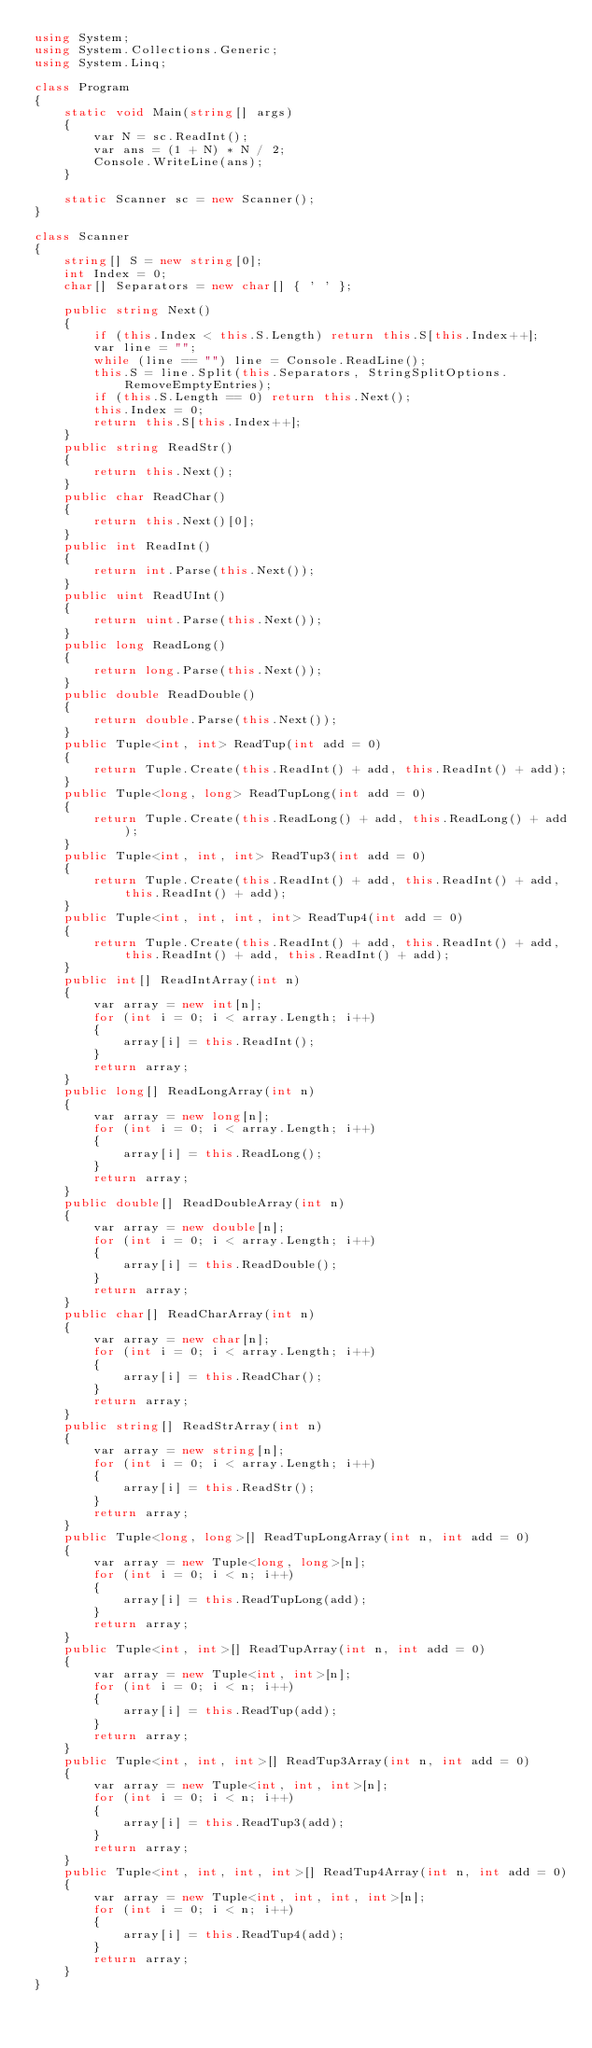Convert code to text. <code><loc_0><loc_0><loc_500><loc_500><_C#_>using System;
using System.Collections.Generic;
using System.Linq;

class Program
{
    static void Main(string[] args)
    {
        var N = sc.ReadInt();
        var ans = (1 + N) * N / 2;
        Console.WriteLine(ans);
    }

    static Scanner sc = new Scanner();
}

class Scanner
{
    string[] S = new string[0];
    int Index = 0;
    char[] Separators = new char[] { ' ' };

    public string Next()
    {
        if (this.Index < this.S.Length) return this.S[this.Index++];
        var line = "";
        while (line == "") line = Console.ReadLine();
        this.S = line.Split(this.Separators, StringSplitOptions.RemoveEmptyEntries);
        if (this.S.Length == 0) return this.Next();
        this.Index = 0;
        return this.S[this.Index++];
    }
    public string ReadStr()
    {
        return this.Next();
    }
    public char ReadChar()
    {
        return this.Next()[0];
    }
    public int ReadInt()
    {
        return int.Parse(this.Next());
    }
    public uint ReadUInt()
    {
        return uint.Parse(this.Next());
    }
    public long ReadLong()
    {
        return long.Parse(this.Next());
    }
    public double ReadDouble()
    {
        return double.Parse(this.Next());
    }
    public Tuple<int, int> ReadTup(int add = 0)
    {
        return Tuple.Create(this.ReadInt() + add, this.ReadInt() + add);
    }
    public Tuple<long, long> ReadTupLong(int add = 0)
    {
        return Tuple.Create(this.ReadLong() + add, this.ReadLong() + add);
    }
    public Tuple<int, int, int> ReadTup3(int add = 0)
    {
        return Tuple.Create(this.ReadInt() + add, this.ReadInt() + add, this.ReadInt() + add);
    }
    public Tuple<int, int, int, int> ReadTup4(int add = 0)
    {
        return Tuple.Create(this.ReadInt() + add, this.ReadInt() + add, this.ReadInt() + add, this.ReadInt() + add);
    }
    public int[] ReadIntArray(int n)
    {
        var array = new int[n];
        for (int i = 0; i < array.Length; i++)
        {
            array[i] = this.ReadInt();
        }
        return array;
    }
    public long[] ReadLongArray(int n)
    {
        var array = new long[n];
        for (int i = 0; i < array.Length; i++)
        {
            array[i] = this.ReadLong();
        }
        return array;
    }
    public double[] ReadDoubleArray(int n)
    {
        var array = new double[n];
        for (int i = 0; i < array.Length; i++)
        {
            array[i] = this.ReadDouble();
        }
        return array;
    }
    public char[] ReadCharArray(int n)
    {
        var array = new char[n];
        for (int i = 0; i < array.Length; i++)
        {
            array[i] = this.ReadChar();
        }
        return array;
    }
    public string[] ReadStrArray(int n)
    {
        var array = new string[n];
        for (int i = 0; i < array.Length; i++)
        {
            array[i] = this.ReadStr();
        }
        return array;
    }
    public Tuple<long, long>[] ReadTupLongArray(int n, int add = 0)
    {
        var array = new Tuple<long, long>[n];
        for (int i = 0; i < n; i++)
        {
            array[i] = this.ReadTupLong(add);
        }
        return array;
    }
    public Tuple<int, int>[] ReadTupArray(int n, int add = 0)
    {
        var array = new Tuple<int, int>[n];
        for (int i = 0; i < n; i++)
        {
            array[i] = this.ReadTup(add);
        }
        return array;
    }
    public Tuple<int, int, int>[] ReadTup3Array(int n, int add = 0)
    {
        var array = new Tuple<int, int, int>[n];
        for (int i = 0; i < n; i++)
        {
            array[i] = this.ReadTup3(add);
        }
        return array;
    }
    public Tuple<int, int, int, int>[] ReadTup4Array(int n, int add = 0)
    {
        var array = new Tuple<int, int, int, int>[n];
        for (int i = 0; i < n; i++)
        {
            array[i] = this.ReadTup4(add);
        }
        return array;
    }
}
</code> 